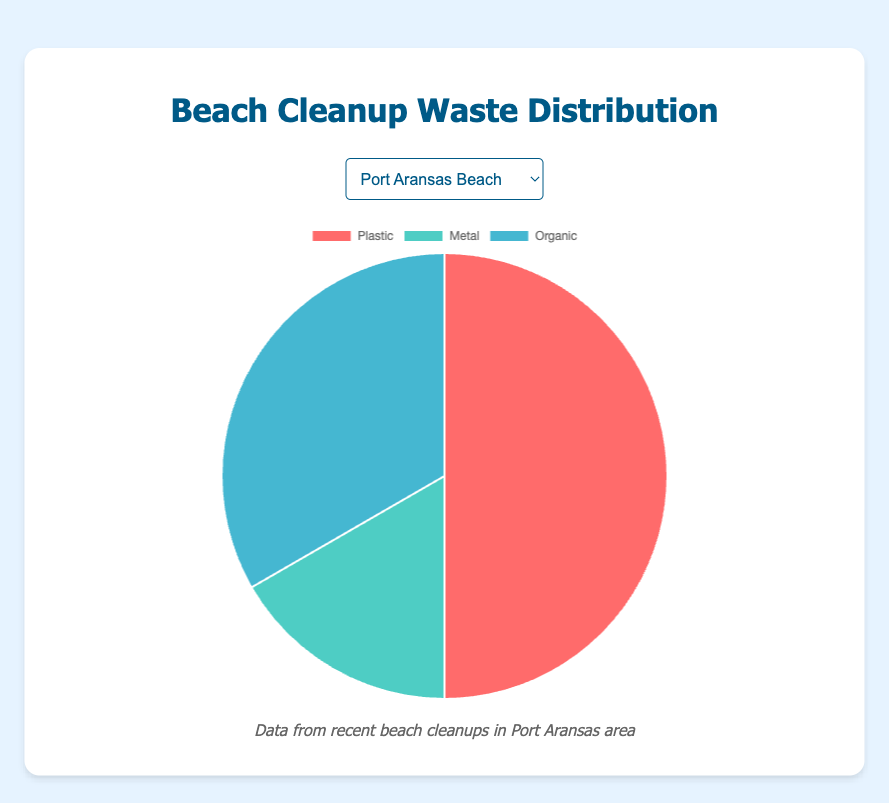What's the percentage of plastic waste collected at Mustang Island? To calculate the percentage, first add up all the collected waste at Mustang Island (300 plastic + 80 metal + 120 organic = 500 units). Then, divide the amount of plastic by the total and multiply by 100 (300/500 * 100 = 60%).
Answer: 60% Which beach location had the highest amount of metal waste? By looking at all the collected metal waste data: Port Aransas Beach (50), Mustang Island (80), IB Magee Beach Park (60), Horace Caldwell Pier (90). Horace Caldwell Pier has the highest amount (90 units).
Answer: Horace Caldwell Pier Which waste type is the smallest portion at Port Aransas Beach? By checking the collected waste data for Port Aransas Beach: Plastic (150), Metal (50), Organic (100). Metal is the smallest portion with 50 units.
Answer: Metal What is the total amount of waste collected at IB Magee Beach Park? Sum up the waste collected at IB Magee Beach Park: Plastic (200) + Metal (60) + Organic (140) = 400 units.
Answer: 400 units Is the amount of organic waste collected more or less than the plastic waste at Horace Caldwell Pier? Compare the collected waste data: Plastic (250), Organic (110). The amount of organic waste is less than the plastic waste.
Answer: Less If you combine the amount of plastic and metal waste at Mustang Island, how much is that? Add the plastic and metal waste collected at Mustang Island: Plastic (300) + Metal (80) = 380 units.
Answer: 380 units Which location had the lowest amount of organic waste collected? By looking at all the locations' organic waste collection: Port Aransas Beach (100), Mustang Island (120), IB Magee Beach Park (140), Horace Caldwell Pier (110). Port Aransas Beach has the lowest (100 units).
Answer: Port Aransas Beach Is the total waste at Port Aransas Beach greater than the total waste at Mustang Island? Calculate the total waste at both locations: Port Aransas Beach (150 Plastic + 50 Metal + 100 Organic = 300 units), Mustang Island (300 Plastic + 80 Metal + 120 Organic = 500 units). No, Port Aransas Beach has less (300 units) compared to Mustang Island (500 units).
Answer: No 